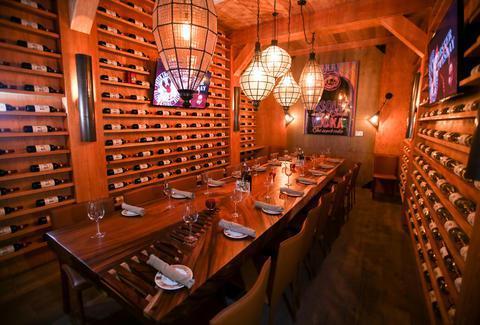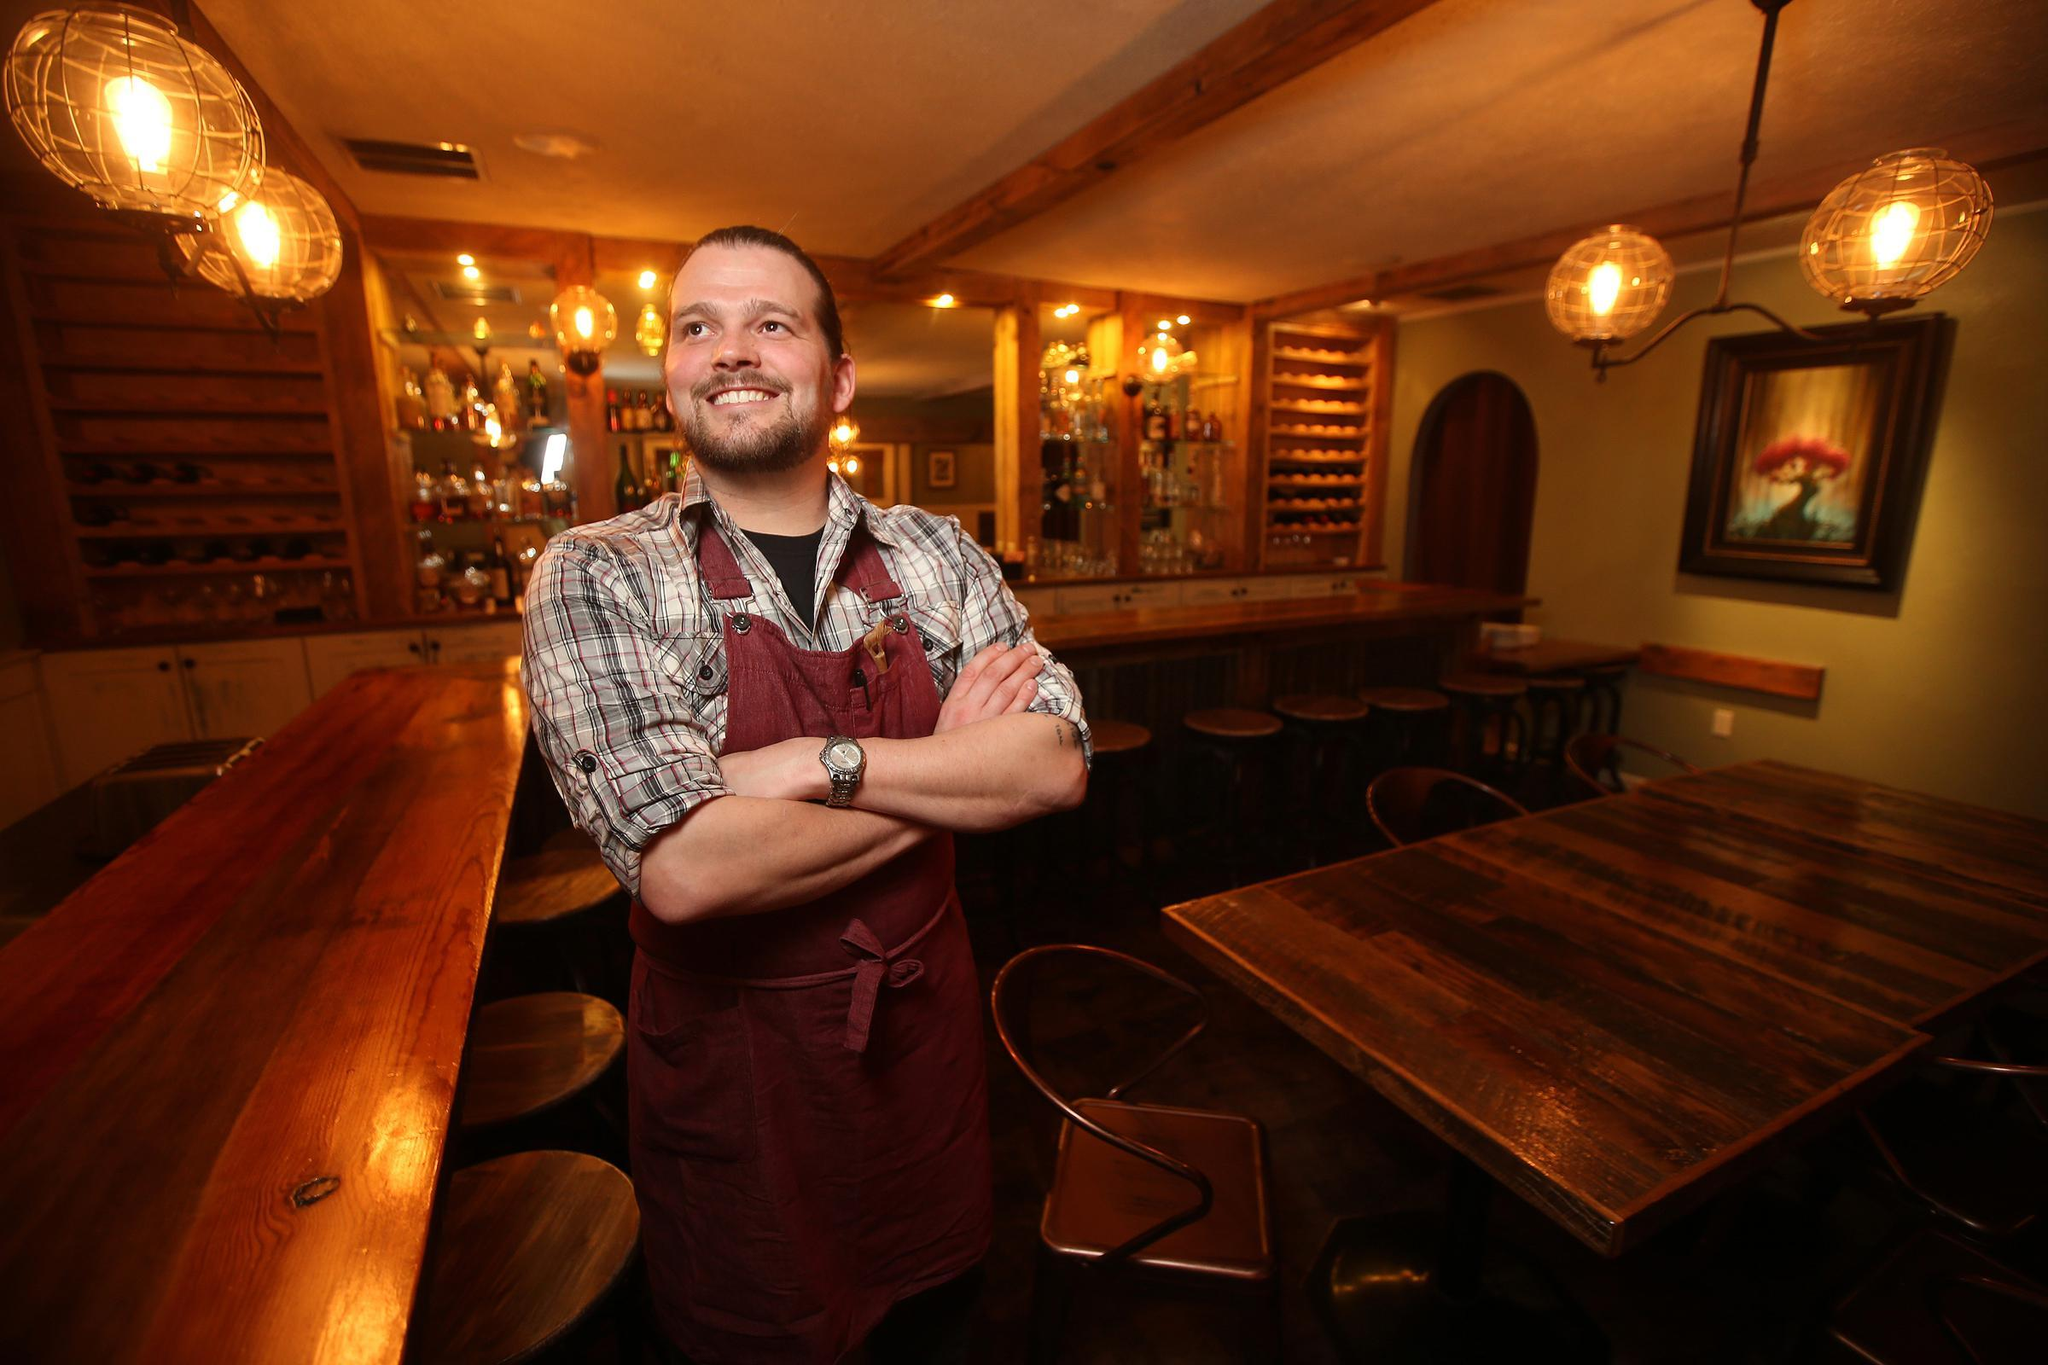The first image is the image on the left, the second image is the image on the right. Evaluate the accuracy of this statement regarding the images: "In the left image, light fixtures with round bottoms suspend over a row of tables with windows to their right, and the restaurant is packed with customers.". Is it true? Answer yes or no. No. 